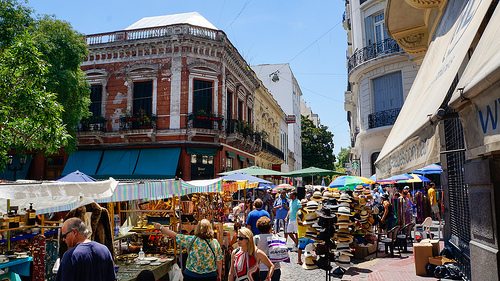<image>
Can you confirm if the tree is behind the building? No. The tree is not behind the building. From this viewpoint, the tree appears to be positioned elsewhere in the scene. 